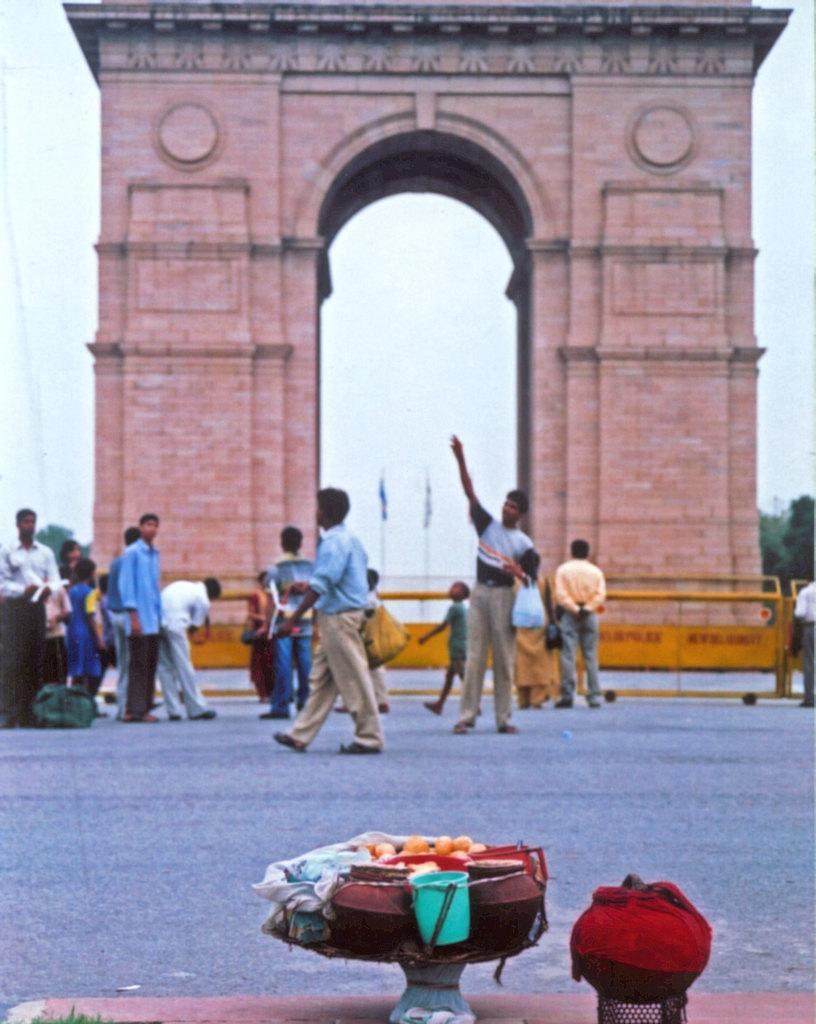Could you give a brief overview of what you see in this image? In the foreground of this image, at the bottom there are few objects. In the middle, there are few people standing and walking on the road. Behind it, there are safety boards, monument wall, trees, flags and the sky. 